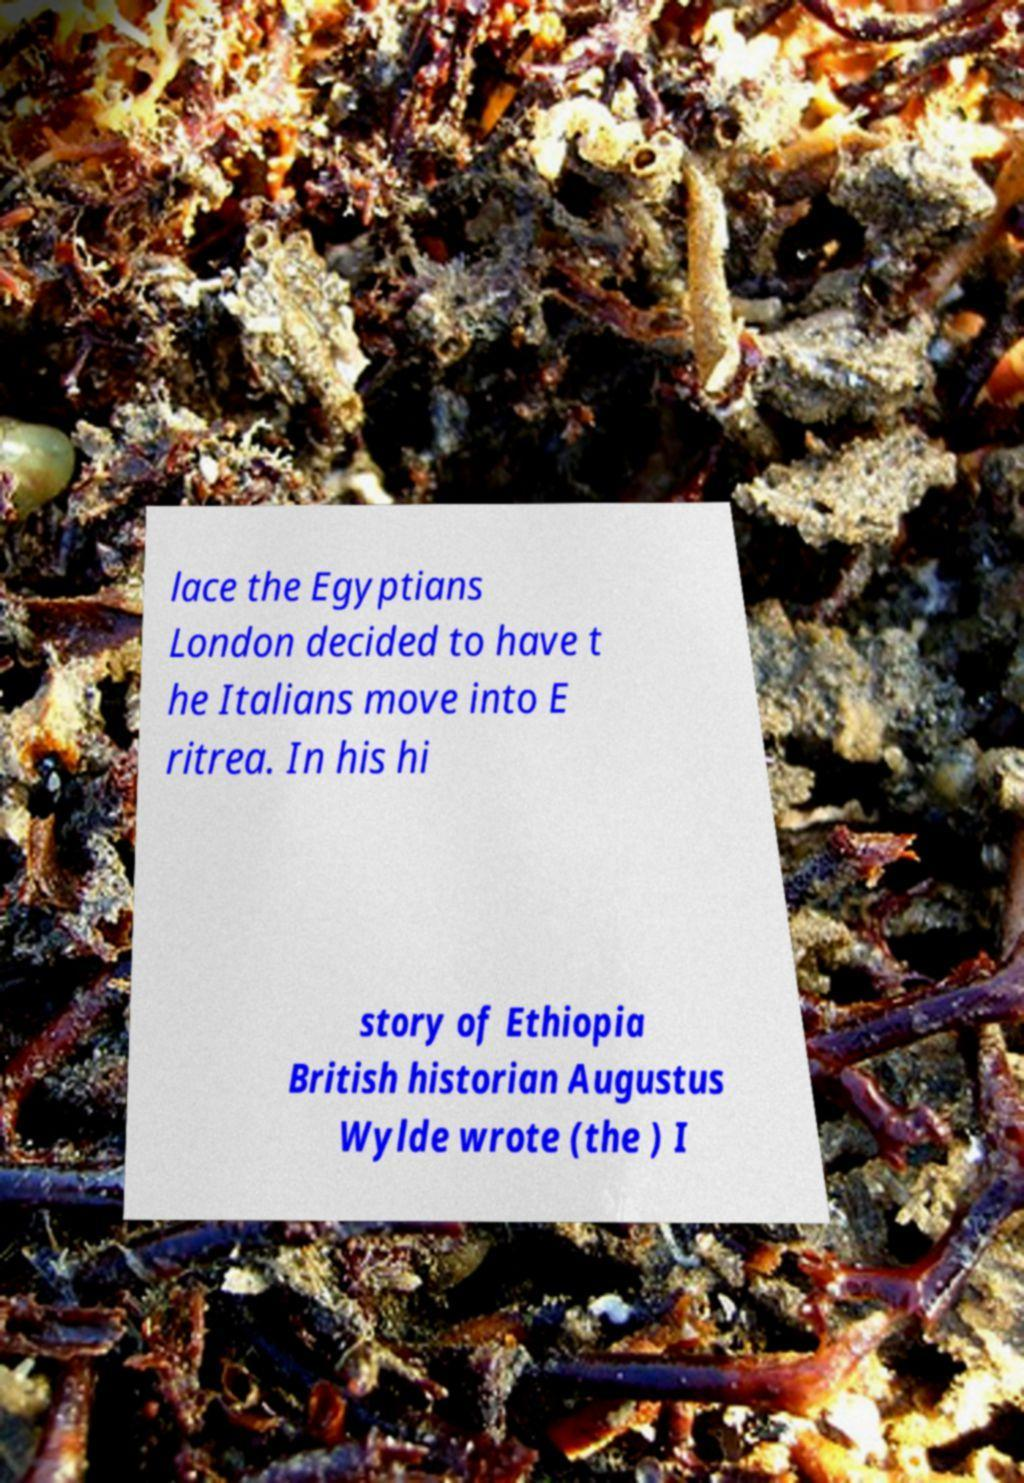There's text embedded in this image that I need extracted. Can you transcribe it verbatim? lace the Egyptians London decided to have t he Italians move into E ritrea. In his hi story of Ethiopia British historian Augustus Wylde wrote (the ) I 